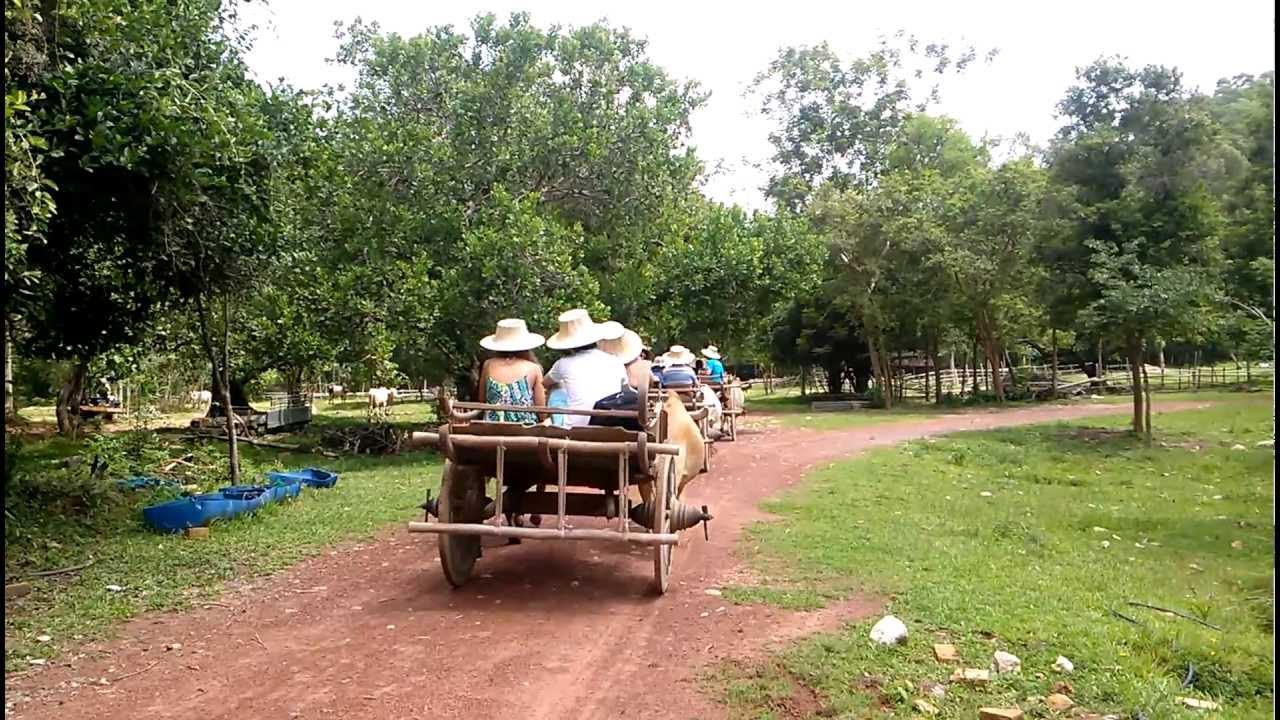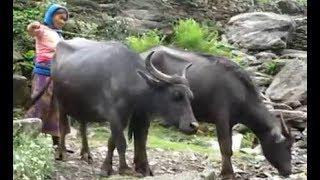The first image is the image on the left, the second image is the image on the right. For the images shown, is this caption "Four oxen are pulling carts with at least one person riding in them." true? Answer yes or no. No. The first image is the image on the left, the second image is the image on the right. Considering the images on both sides, is "The oxen in the image on the right are wearing decorative headgear." valid? Answer yes or no. No. 